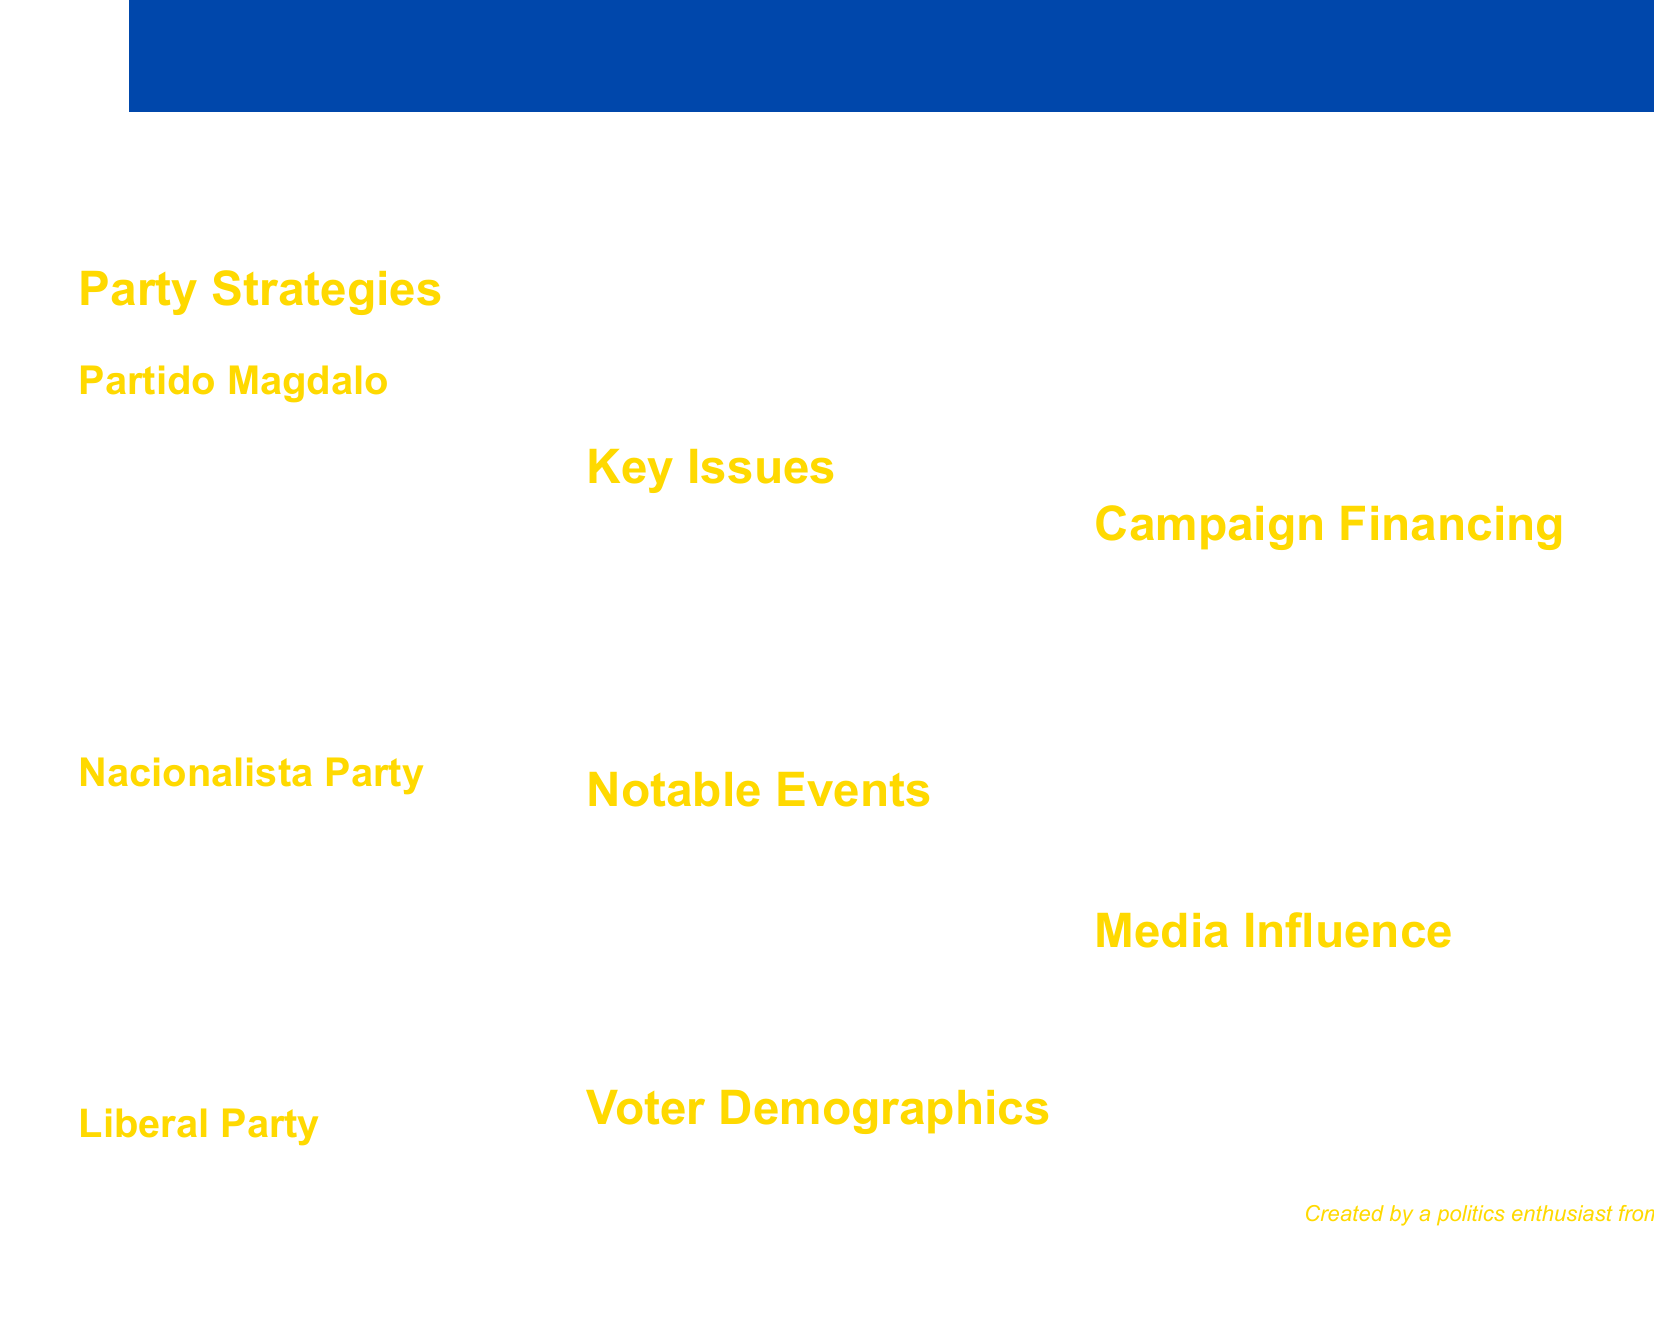What are the parties involved in the election? The document lists multiple political parties engaged in the election, namely Partido Magdalo, Nacionalista Party, and Liberal Party.
Answer: Partido Magdalo, Nacionalista Party, Liberal Party Which party focused on social media platforms? The document states that Partido Magdalo extensively used social media platforms, particularly Facebook and TikTok.
Answer: Partido Magdalo What percentage of registered voters are youth voters? The document specifies that youth voters account for 40% of the total registered voters in Cavite.
Answer: 40% What was the average spending per party during the campaigns? The average spending mentioned in the document is 50 million pesos per party.
Answer: ₱50 million Which party organized the Cavite Youth Summit? The document indicates that Partido Magdalo organized the Cavite Youth Summit to engage young voters.
Answer: Partido Magdalo What key issue is related to Manila Bay? The document outlines environmental protection, particularly concerning Manila Bay, as one of the key issues in the election.
Answer: Environmental protection Who was the top spender in campaign financing? The document identifies the Nacionalista Party as the top spender in campaign financing.
Answer: Nacionalista Party What type of events did the Liberal Party focus on? The document mentions that the Liberal Party concentrated on youth-oriented events and concerts as part of their strategies.
Answer: Youth-oriented events and concerts What role did local radio stations play in the campaign? The document states that local radio stations played a crucial role in reaching rural voters during the campaign.
Answer: Crucial role in reaching rural voters 